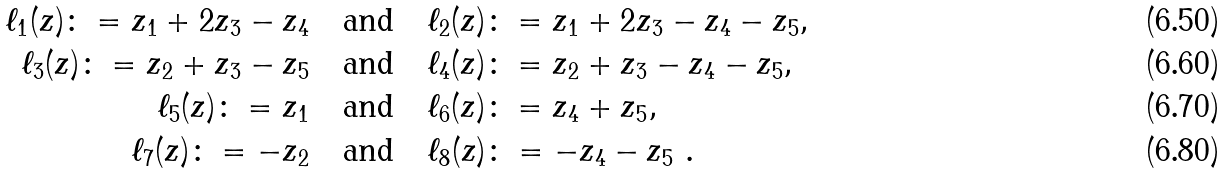Convert formula to latex. <formula><loc_0><loc_0><loc_500><loc_500>\ell _ { 1 } ( z ) \colon = z _ { 1 } + 2 z _ { 3 } - z _ { 4 } \quad & \text {and} \quad \ell _ { 2 } ( z ) \colon = z _ { 1 } + 2 z _ { 3 } - z _ { 4 } - z _ { 5 } , \\ \ell _ { 3 } ( z ) \colon = z _ { 2 } + z _ { 3 } - z _ { 5 } \quad & \text {and} \quad \ell _ { 4 } ( z ) \colon = z _ { 2 } + z _ { 3 } - z _ { 4 } - z _ { 5 } , \\ \ell _ { 5 } ( z ) \colon = z _ { 1 } \quad & \text {and} \quad \ell _ { 6 } ( z ) \colon = z _ { 4 } + z _ { 5 } , \\ \ell _ { 7 } ( z ) \colon = - z _ { 2 } \quad & \text {and} \quad \ell _ { 8 } ( z ) \colon = - z _ { 4 } - z _ { 5 } \ .</formula> 